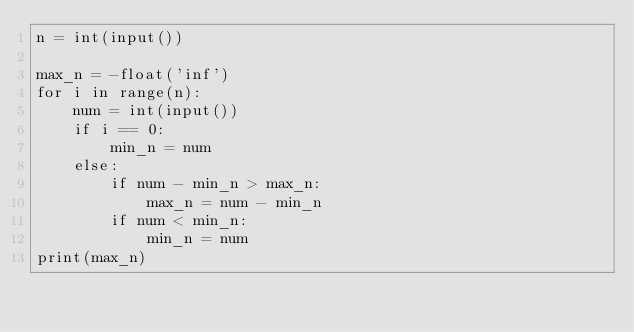<code> <loc_0><loc_0><loc_500><loc_500><_Python_>n = int(input())

max_n = -float('inf')
for i in range(n):
    num = int(input())
    if i == 0:
        min_n = num
    else:
        if num - min_n > max_n:
            max_n = num - min_n
        if num < min_n:
            min_n = num
print(max_n)

    
    

</code> 